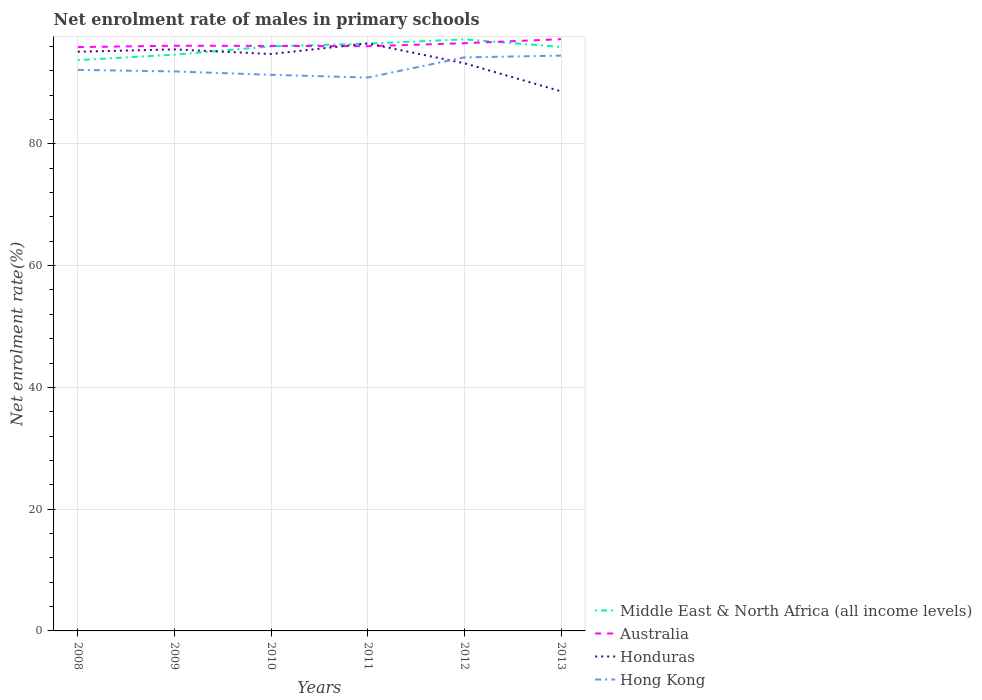How many different coloured lines are there?
Your answer should be compact. 4. Does the line corresponding to Honduras intersect with the line corresponding to Hong Kong?
Offer a very short reply. Yes. Is the number of lines equal to the number of legend labels?
Provide a succinct answer. Yes. Across all years, what is the maximum net enrolment rate of males in primary schools in Honduras?
Offer a very short reply. 88.63. In which year was the net enrolment rate of males in primary schools in Hong Kong maximum?
Make the answer very short. 2011. What is the total net enrolment rate of males in primary schools in Honduras in the graph?
Provide a short and direct response. 0.76. What is the difference between the highest and the second highest net enrolment rate of males in primary schools in Honduras?
Your response must be concise. 7.86. What is the difference between the highest and the lowest net enrolment rate of males in primary schools in Middle East & North Africa (all income levels)?
Provide a succinct answer. 4. Is the net enrolment rate of males in primary schools in Middle East & North Africa (all income levels) strictly greater than the net enrolment rate of males in primary schools in Australia over the years?
Offer a very short reply. No. How many lines are there?
Keep it short and to the point. 4. What is the difference between two consecutive major ticks on the Y-axis?
Ensure brevity in your answer.  20. Does the graph contain grids?
Your answer should be compact. Yes. How are the legend labels stacked?
Your answer should be very brief. Vertical. What is the title of the graph?
Ensure brevity in your answer.  Net enrolment rate of males in primary schools. What is the label or title of the Y-axis?
Keep it short and to the point. Net enrolment rate(%). What is the Net enrolment rate(%) in Middle East & North Africa (all income levels) in 2008?
Your response must be concise. 93.74. What is the Net enrolment rate(%) of Australia in 2008?
Your answer should be very brief. 95.89. What is the Net enrolment rate(%) in Honduras in 2008?
Your answer should be very brief. 95.13. What is the Net enrolment rate(%) in Hong Kong in 2008?
Make the answer very short. 92.14. What is the Net enrolment rate(%) of Middle East & North Africa (all income levels) in 2009?
Keep it short and to the point. 94.65. What is the Net enrolment rate(%) in Australia in 2009?
Ensure brevity in your answer.  96.11. What is the Net enrolment rate(%) in Honduras in 2009?
Offer a terse response. 95.51. What is the Net enrolment rate(%) of Hong Kong in 2009?
Your response must be concise. 91.89. What is the Net enrolment rate(%) in Middle East & North Africa (all income levels) in 2010?
Offer a terse response. 96.01. What is the Net enrolment rate(%) in Australia in 2010?
Provide a succinct answer. 96.09. What is the Net enrolment rate(%) of Honduras in 2010?
Make the answer very short. 94.75. What is the Net enrolment rate(%) of Hong Kong in 2010?
Give a very brief answer. 91.34. What is the Net enrolment rate(%) in Middle East & North Africa (all income levels) in 2011?
Ensure brevity in your answer.  96.46. What is the Net enrolment rate(%) in Australia in 2011?
Offer a terse response. 96.03. What is the Net enrolment rate(%) in Honduras in 2011?
Your answer should be very brief. 96.49. What is the Net enrolment rate(%) in Hong Kong in 2011?
Offer a terse response. 90.89. What is the Net enrolment rate(%) of Middle East & North Africa (all income levels) in 2012?
Ensure brevity in your answer.  97.16. What is the Net enrolment rate(%) of Australia in 2012?
Provide a succinct answer. 96.53. What is the Net enrolment rate(%) in Honduras in 2012?
Provide a short and direct response. 93.24. What is the Net enrolment rate(%) in Hong Kong in 2012?
Offer a very short reply. 94.2. What is the Net enrolment rate(%) in Middle East & North Africa (all income levels) in 2013?
Make the answer very short. 95.92. What is the Net enrolment rate(%) in Australia in 2013?
Provide a succinct answer. 97.19. What is the Net enrolment rate(%) of Honduras in 2013?
Your answer should be very brief. 88.63. What is the Net enrolment rate(%) of Hong Kong in 2013?
Offer a very short reply. 94.49. Across all years, what is the maximum Net enrolment rate(%) of Middle East & North Africa (all income levels)?
Keep it short and to the point. 97.16. Across all years, what is the maximum Net enrolment rate(%) of Australia?
Make the answer very short. 97.19. Across all years, what is the maximum Net enrolment rate(%) in Honduras?
Give a very brief answer. 96.49. Across all years, what is the maximum Net enrolment rate(%) in Hong Kong?
Offer a terse response. 94.49. Across all years, what is the minimum Net enrolment rate(%) in Middle East & North Africa (all income levels)?
Provide a succinct answer. 93.74. Across all years, what is the minimum Net enrolment rate(%) of Australia?
Offer a terse response. 95.89. Across all years, what is the minimum Net enrolment rate(%) of Honduras?
Your answer should be compact. 88.63. Across all years, what is the minimum Net enrolment rate(%) of Hong Kong?
Ensure brevity in your answer.  90.89. What is the total Net enrolment rate(%) of Middle East & North Africa (all income levels) in the graph?
Offer a very short reply. 573.94. What is the total Net enrolment rate(%) in Australia in the graph?
Ensure brevity in your answer.  577.84. What is the total Net enrolment rate(%) in Honduras in the graph?
Your answer should be compact. 563.76. What is the total Net enrolment rate(%) of Hong Kong in the graph?
Ensure brevity in your answer.  554.95. What is the difference between the Net enrolment rate(%) in Middle East & North Africa (all income levels) in 2008 and that in 2009?
Make the answer very short. -0.9. What is the difference between the Net enrolment rate(%) in Australia in 2008 and that in 2009?
Give a very brief answer. -0.23. What is the difference between the Net enrolment rate(%) in Honduras in 2008 and that in 2009?
Ensure brevity in your answer.  -0.38. What is the difference between the Net enrolment rate(%) in Hong Kong in 2008 and that in 2009?
Make the answer very short. 0.25. What is the difference between the Net enrolment rate(%) of Middle East & North Africa (all income levels) in 2008 and that in 2010?
Your answer should be very brief. -2.27. What is the difference between the Net enrolment rate(%) of Australia in 2008 and that in 2010?
Offer a terse response. -0.2. What is the difference between the Net enrolment rate(%) in Honduras in 2008 and that in 2010?
Offer a terse response. 0.38. What is the difference between the Net enrolment rate(%) in Hong Kong in 2008 and that in 2010?
Keep it short and to the point. 0.81. What is the difference between the Net enrolment rate(%) of Middle East & North Africa (all income levels) in 2008 and that in 2011?
Make the answer very short. -2.72. What is the difference between the Net enrolment rate(%) of Australia in 2008 and that in 2011?
Provide a succinct answer. -0.15. What is the difference between the Net enrolment rate(%) of Honduras in 2008 and that in 2011?
Make the answer very short. -1.36. What is the difference between the Net enrolment rate(%) in Hong Kong in 2008 and that in 2011?
Offer a very short reply. 1.25. What is the difference between the Net enrolment rate(%) of Middle East & North Africa (all income levels) in 2008 and that in 2012?
Keep it short and to the point. -3.42. What is the difference between the Net enrolment rate(%) of Australia in 2008 and that in 2012?
Provide a short and direct response. -0.64. What is the difference between the Net enrolment rate(%) of Honduras in 2008 and that in 2012?
Your answer should be very brief. 1.89. What is the difference between the Net enrolment rate(%) of Hong Kong in 2008 and that in 2012?
Your answer should be very brief. -2.05. What is the difference between the Net enrolment rate(%) in Middle East & North Africa (all income levels) in 2008 and that in 2013?
Your answer should be very brief. -2.17. What is the difference between the Net enrolment rate(%) in Australia in 2008 and that in 2013?
Keep it short and to the point. -1.3. What is the difference between the Net enrolment rate(%) of Honduras in 2008 and that in 2013?
Give a very brief answer. 6.5. What is the difference between the Net enrolment rate(%) in Hong Kong in 2008 and that in 2013?
Keep it short and to the point. -2.34. What is the difference between the Net enrolment rate(%) in Middle East & North Africa (all income levels) in 2009 and that in 2010?
Your answer should be compact. -1.37. What is the difference between the Net enrolment rate(%) in Australia in 2009 and that in 2010?
Offer a very short reply. 0.03. What is the difference between the Net enrolment rate(%) in Honduras in 2009 and that in 2010?
Provide a short and direct response. 0.76. What is the difference between the Net enrolment rate(%) in Hong Kong in 2009 and that in 2010?
Offer a terse response. 0.56. What is the difference between the Net enrolment rate(%) of Middle East & North Africa (all income levels) in 2009 and that in 2011?
Your answer should be compact. -1.82. What is the difference between the Net enrolment rate(%) in Australia in 2009 and that in 2011?
Keep it short and to the point. 0.08. What is the difference between the Net enrolment rate(%) of Honduras in 2009 and that in 2011?
Your answer should be compact. -0.98. What is the difference between the Net enrolment rate(%) of Middle East & North Africa (all income levels) in 2009 and that in 2012?
Your response must be concise. -2.51. What is the difference between the Net enrolment rate(%) in Australia in 2009 and that in 2012?
Give a very brief answer. -0.42. What is the difference between the Net enrolment rate(%) of Honduras in 2009 and that in 2012?
Keep it short and to the point. 2.28. What is the difference between the Net enrolment rate(%) in Hong Kong in 2009 and that in 2012?
Your answer should be compact. -2.31. What is the difference between the Net enrolment rate(%) of Middle East & North Africa (all income levels) in 2009 and that in 2013?
Give a very brief answer. -1.27. What is the difference between the Net enrolment rate(%) of Australia in 2009 and that in 2013?
Your answer should be compact. -1.07. What is the difference between the Net enrolment rate(%) in Honduras in 2009 and that in 2013?
Make the answer very short. 6.88. What is the difference between the Net enrolment rate(%) of Hong Kong in 2009 and that in 2013?
Your answer should be very brief. -2.6. What is the difference between the Net enrolment rate(%) of Middle East & North Africa (all income levels) in 2010 and that in 2011?
Your answer should be compact. -0.45. What is the difference between the Net enrolment rate(%) of Australia in 2010 and that in 2011?
Your response must be concise. 0.05. What is the difference between the Net enrolment rate(%) in Honduras in 2010 and that in 2011?
Ensure brevity in your answer.  -1.74. What is the difference between the Net enrolment rate(%) in Hong Kong in 2010 and that in 2011?
Ensure brevity in your answer.  0.45. What is the difference between the Net enrolment rate(%) of Middle East & North Africa (all income levels) in 2010 and that in 2012?
Provide a short and direct response. -1.14. What is the difference between the Net enrolment rate(%) of Australia in 2010 and that in 2012?
Your answer should be compact. -0.45. What is the difference between the Net enrolment rate(%) of Honduras in 2010 and that in 2012?
Your answer should be very brief. 1.52. What is the difference between the Net enrolment rate(%) of Hong Kong in 2010 and that in 2012?
Your answer should be very brief. -2.86. What is the difference between the Net enrolment rate(%) in Middle East & North Africa (all income levels) in 2010 and that in 2013?
Provide a short and direct response. 0.1. What is the difference between the Net enrolment rate(%) in Australia in 2010 and that in 2013?
Your answer should be compact. -1.1. What is the difference between the Net enrolment rate(%) of Honduras in 2010 and that in 2013?
Ensure brevity in your answer.  6.12. What is the difference between the Net enrolment rate(%) in Hong Kong in 2010 and that in 2013?
Offer a terse response. -3.15. What is the difference between the Net enrolment rate(%) of Middle East & North Africa (all income levels) in 2011 and that in 2012?
Give a very brief answer. -0.7. What is the difference between the Net enrolment rate(%) of Australia in 2011 and that in 2012?
Your answer should be very brief. -0.5. What is the difference between the Net enrolment rate(%) of Honduras in 2011 and that in 2012?
Your answer should be very brief. 3.26. What is the difference between the Net enrolment rate(%) of Hong Kong in 2011 and that in 2012?
Give a very brief answer. -3.31. What is the difference between the Net enrolment rate(%) in Middle East & North Africa (all income levels) in 2011 and that in 2013?
Provide a succinct answer. 0.55. What is the difference between the Net enrolment rate(%) of Australia in 2011 and that in 2013?
Ensure brevity in your answer.  -1.15. What is the difference between the Net enrolment rate(%) of Honduras in 2011 and that in 2013?
Your answer should be very brief. 7.86. What is the difference between the Net enrolment rate(%) in Hong Kong in 2011 and that in 2013?
Ensure brevity in your answer.  -3.6. What is the difference between the Net enrolment rate(%) of Middle East & North Africa (all income levels) in 2012 and that in 2013?
Your response must be concise. 1.24. What is the difference between the Net enrolment rate(%) in Australia in 2012 and that in 2013?
Your answer should be very brief. -0.66. What is the difference between the Net enrolment rate(%) in Honduras in 2012 and that in 2013?
Your response must be concise. 4.61. What is the difference between the Net enrolment rate(%) in Hong Kong in 2012 and that in 2013?
Keep it short and to the point. -0.29. What is the difference between the Net enrolment rate(%) in Middle East & North Africa (all income levels) in 2008 and the Net enrolment rate(%) in Australia in 2009?
Offer a very short reply. -2.37. What is the difference between the Net enrolment rate(%) of Middle East & North Africa (all income levels) in 2008 and the Net enrolment rate(%) of Honduras in 2009?
Provide a succinct answer. -1.77. What is the difference between the Net enrolment rate(%) of Middle East & North Africa (all income levels) in 2008 and the Net enrolment rate(%) of Hong Kong in 2009?
Provide a short and direct response. 1.85. What is the difference between the Net enrolment rate(%) of Australia in 2008 and the Net enrolment rate(%) of Honduras in 2009?
Your answer should be very brief. 0.38. What is the difference between the Net enrolment rate(%) in Australia in 2008 and the Net enrolment rate(%) in Hong Kong in 2009?
Keep it short and to the point. 3.99. What is the difference between the Net enrolment rate(%) of Honduras in 2008 and the Net enrolment rate(%) of Hong Kong in 2009?
Ensure brevity in your answer.  3.24. What is the difference between the Net enrolment rate(%) in Middle East & North Africa (all income levels) in 2008 and the Net enrolment rate(%) in Australia in 2010?
Ensure brevity in your answer.  -2.34. What is the difference between the Net enrolment rate(%) of Middle East & North Africa (all income levels) in 2008 and the Net enrolment rate(%) of Honduras in 2010?
Ensure brevity in your answer.  -1.01. What is the difference between the Net enrolment rate(%) in Middle East & North Africa (all income levels) in 2008 and the Net enrolment rate(%) in Hong Kong in 2010?
Provide a succinct answer. 2.41. What is the difference between the Net enrolment rate(%) in Australia in 2008 and the Net enrolment rate(%) in Honduras in 2010?
Provide a succinct answer. 1.13. What is the difference between the Net enrolment rate(%) in Australia in 2008 and the Net enrolment rate(%) in Hong Kong in 2010?
Offer a very short reply. 4.55. What is the difference between the Net enrolment rate(%) of Honduras in 2008 and the Net enrolment rate(%) of Hong Kong in 2010?
Make the answer very short. 3.79. What is the difference between the Net enrolment rate(%) in Middle East & North Africa (all income levels) in 2008 and the Net enrolment rate(%) in Australia in 2011?
Provide a short and direct response. -2.29. What is the difference between the Net enrolment rate(%) of Middle East & North Africa (all income levels) in 2008 and the Net enrolment rate(%) of Honduras in 2011?
Offer a very short reply. -2.75. What is the difference between the Net enrolment rate(%) of Middle East & North Africa (all income levels) in 2008 and the Net enrolment rate(%) of Hong Kong in 2011?
Offer a very short reply. 2.85. What is the difference between the Net enrolment rate(%) in Australia in 2008 and the Net enrolment rate(%) in Honduras in 2011?
Ensure brevity in your answer.  -0.61. What is the difference between the Net enrolment rate(%) in Australia in 2008 and the Net enrolment rate(%) in Hong Kong in 2011?
Provide a short and direct response. 5. What is the difference between the Net enrolment rate(%) of Honduras in 2008 and the Net enrolment rate(%) of Hong Kong in 2011?
Give a very brief answer. 4.24. What is the difference between the Net enrolment rate(%) in Middle East & North Africa (all income levels) in 2008 and the Net enrolment rate(%) in Australia in 2012?
Offer a terse response. -2.79. What is the difference between the Net enrolment rate(%) in Middle East & North Africa (all income levels) in 2008 and the Net enrolment rate(%) in Honduras in 2012?
Ensure brevity in your answer.  0.51. What is the difference between the Net enrolment rate(%) of Middle East & North Africa (all income levels) in 2008 and the Net enrolment rate(%) of Hong Kong in 2012?
Make the answer very short. -0.46. What is the difference between the Net enrolment rate(%) of Australia in 2008 and the Net enrolment rate(%) of Honduras in 2012?
Give a very brief answer. 2.65. What is the difference between the Net enrolment rate(%) of Australia in 2008 and the Net enrolment rate(%) of Hong Kong in 2012?
Offer a terse response. 1.69. What is the difference between the Net enrolment rate(%) of Honduras in 2008 and the Net enrolment rate(%) of Hong Kong in 2012?
Your response must be concise. 0.93. What is the difference between the Net enrolment rate(%) of Middle East & North Africa (all income levels) in 2008 and the Net enrolment rate(%) of Australia in 2013?
Provide a succinct answer. -3.45. What is the difference between the Net enrolment rate(%) in Middle East & North Africa (all income levels) in 2008 and the Net enrolment rate(%) in Honduras in 2013?
Ensure brevity in your answer.  5.11. What is the difference between the Net enrolment rate(%) of Middle East & North Africa (all income levels) in 2008 and the Net enrolment rate(%) of Hong Kong in 2013?
Provide a short and direct response. -0.75. What is the difference between the Net enrolment rate(%) in Australia in 2008 and the Net enrolment rate(%) in Honduras in 2013?
Your answer should be compact. 7.26. What is the difference between the Net enrolment rate(%) of Australia in 2008 and the Net enrolment rate(%) of Hong Kong in 2013?
Your response must be concise. 1.4. What is the difference between the Net enrolment rate(%) in Honduras in 2008 and the Net enrolment rate(%) in Hong Kong in 2013?
Your response must be concise. 0.64. What is the difference between the Net enrolment rate(%) of Middle East & North Africa (all income levels) in 2009 and the Net enrolment rate(%) of Australia in 2010?
Make the answer very short. -1.44. What is the difference between the Net enrolment rate(%) of Middle East & North Africa (all income levels) in 2009 and the Net enrolment rate(%) of Honduras in 2010?
Your answer should be very brief. -0.11. What is the difference between the Net enrolment rate(%) in Middle East & North Africa (all income levels) in 2009 and the Net enrolment rate(%) in Hong Kong in 2010?
Ensure brevity in your answer.  3.31. What is the difference between the Net enrolment rate(%) in Australia in 2009 and the Net enrolment rate(%) in Honduras in 2010?
Your answer should be compact. 1.36. What is the difference between the Net enrolment rate(%) in Australia in 2009 and the Net enrolment rate(%) in Hong Kong in 2010?
Provide a short and direct response. 4.78. What is the difference between the Net enrolment rate(%) of Honduras in 2009 and the Net enrolment rate(%) of Hong Kong in 2010?
Offer a very short reply. 4.18. What is the difference between the Net enrolment rate(%) in Middle East & North Africa (all income levels) in 2009 and the Net enrolment rate(%) in Australia in 2011?
Offer a very short reply. -1.39. What is the difference between the Net enrolment rate(%) in Middle East & North Africa (all income levels) in 2009 and the Net enrolment rate(%) in Honduras in 2011?
Provide a succinct answer. -1.85. What is the difference between the Net enrolment rate(%) in Middle East & North Africa (all income levels) in 2009 and the Net enrolment rate(%) in Hong Kong in 2011?
Your response must be concise. 3.75. What is the difference between the Net enrolment rate(%) of Australia in 2009 and the Net enrolment rate(%) of Honduras in 2011?
Provide a short and direct response. -0.38. What is the difference between the Net enrolment rate(%) of Australia in 2009 and the Net enrolment rate(%) of Hong Kong in 2011?
Make the answer very short. 5.22. What is the difference between the Net enrolment rate(%) of Honduras in 2009 and the Net enrolment rate(%) of Hong Kong in 2011?
Give a very brief answer. 4.62. What is the difference between the Net enrolment rate(%) in Middle East & North Africa (all income levels) in 2009 and the Net enrolment rate(%) in Australia in 2012?
Your response must be concise. -1.89. What is the difference between the Net enrolment rate(%) of Middle East & North Africa (all income levels) in 2009 and the Net enrolment rate(%) of Honduras in 2012?
Provide a short and direct response. 1.41. What is the difference between the Net enrolment rate(%) of Middle East & North Africa (all income levels) in 2009 and the Net enrolment rate(%) of Hong Kong in 2012?
Your answer should be compact. 0.45. What is the difference between the Net enrolment rate(%) of Australia in 2009 and the Net enrolment rate(%) of Honduras in 2012?
Offer a very short reply. 2.88. What is the difference between the Net enrolment rate(%) of Australia in 2009 and the Net enrolment rate(%) of Hong Kong in 2012?
Your response must be concise. 1.92. What is the difference between the Net enrolment rate(%) of Honduras in 2009 and the Net enrolment rate(%) of Hong Kong in 2012?
Your answer should be very brief. 1.31. What is the difference between the Net enrolment rate(%) in Middle East & North Africa (all income levels) in 2009 and the Net enrolment rate(%) in Australia in 2013?
Your response must be concise. -2.54. What is the difference between the Net enrolment rate(%) in Middle East & North Africa (all income levels) in 2009 and the Net enrolment rate(%) in Honduras in 2013?
Offer a very short reply. 6.02. What is the difference between the Net enrolment rate(%) in Middle East & North Africa (all income levels) in 2009 and the Net enrolment rate(%) in Hong Kong in 2013?
Give a very brief answer. 0.16. What is the difference between the Net enrolment rate(%) of Australia in 2009 and the Net enrolment rate(%) of Honduras in 2013?
Keep it short and to the point. 7.48. What is the difference between the Net enrolment rate(%) of Australia in 2009 and the Net enrolment rate(%) of Hong Kong in 2013?
Give a very brief answer. 1.62. What is the difference between the Net enrolment rate(%) of Honduras in 2009 and the Net enrolment rate(%) of Hong Kong in 2013?
Your answer should be very brief. 1.02. What is the difference between the Net enrolment rate(%) in Middle East & North Africa (all income levels) in 2010 and the Net enrolment rate(%) in Australia in 2011?
Make the answer very short. -0.02. What is the difference between the Net enrolment rate(%) in Middle East & North Africa (all income levels) in 2010 and the Net enrolment rate(%) in Honduras in 2011?
Your response must be concise. -0.48. What is the difference between the Net enrolment rate(%) in Middle East & North Africa (all income levels) in 2010 and the Net enrolment rate(%) in Hong Kong in 2011?
Ensure brevity in your answer.  5.12. What is the difference between the Net enrolment rate(%) in Australia in 2010 and the Net enrolment rate(%) in Honduras in 2011?
Your answer should be compact. -0.41. What is the difference between the Net enrolment rate(%) of Australia in 2010 and the Net enrolment rate(%) of Hong Kong in 2011?
Give a very brief answer. 5.2. What is the difference between the Net enrolment rate(%) in Honduras in 2010 and the Net enrolment rate(%) in Hong Kong in 2011?
Your response must be concise. 3.86. What is the difference between the Net enrolment rate(%) of Middle East & North Africa (all income levels) in 2010 and the Net enrolment rate(%) of Australia in 2012?
Offer a terse response. -0.52. What is the difference between the Net enrolment rate(%) of Middle East & North Africa (all income levels) in 2010 and the Net enrolment rate(%) of Honduras in 2012?
Offer a very short reply. 2.78. What is the difference between the Net enrolment rate(%) in Middle East & North Africa (all income levels) in 2010 and the Net enrolment rate(%) in Hong Kong in 2012?
Your response must be concise. 1.82. What is the difference between the Net enrolment rate(%) in Australia in 2010 and the Net enrolment rate(%) in Honduras in 2012?
Provide a short and direct response. 2.85. What is the difference between the Net enrolment rate(%) in Australia in 2010 and the Net enrolment rate(%) in Hong Kong in 2012?
Your response must be concise. 1.89. What is the difference between the Net enrolment rate(%) in Honduras in 2010 and the Net enrolment rate(%) in Hong Kong in 2012?
Offer a very short reply. 0.56. What is the difference between the Net enrolment rate(%) in Middle East & North Africa (all income levels) in 2010 and the Net enrolment rate(%) in Australia in 2013?
Keep it short and to the point. -1.17. What is the difference between the Net enrolment rate(%) of Middle East & North Africa (all income levels) in 2010 and the Net enrolment rate(%) of Honduras in 2013?
Provide a short and direct response. 7.38. What is the difference between the Net enrolment rate(%) of Middle East & North Africa (all income levels) in 2010 and the Net enrolment rate(%) of Hong Kong in 2013?
Provide a short and direct response. 1.53. What is the difference between the Net enrolment rate(%) of Australia in 2010 and the Net enrolment rate(%) of Honduras in 2013?
Make the answer very short. 7.46. What is the difference between the Net enrolment rate(%) of Australia in 2010 and the Net enrolment rate(%) of Hong Kong in 2013?
Ensure brevity in your answer.  1.6. What is the difference between the Net enrolment rate(%) in Honduras in 2010 and the Net enrolment rate(%) in Hong Kong in 2013?
Provide a short and direct response. 0.26. What is the difference between the Net enrolment rate(%) in Middle East & North Africa (all income levels) in 2011 and the Net enrolment rate(%) in Australia in 2012?
Offer a terse response. -0.07. What is the difference between the Net enrolment rate(%) of Middle East & North Africa (all income levels) in 2011 and the Net enrolment rate(%) of Honduras in 2012?
Your response must be concise. 3.23. What is the difference between the Net enrolment rate(%) in Middle East & North Africa (all income levels) in 2011 and the Net enrolment rate(%) in Hong Kong in 2012?
Provide a short and direct response. 2.26. What is the difference between the Net enrolment rate(%) in Australia in 2011 and the Net enrolment rate(%) in Honduras in 2012?
Your answer should be very brief. 2.8. What is the difference between the Net enrolment rate(%) of Australia in 2011 and the Net enrolment rate(%) of Hong Kong in 2012?
Your answer should be very brief. 1.84. What is the difference between the Net enrolment rate(%) in Honduras in 2011 and the Net enrolment rate(%) in Hong Kong in 2012?
Give a very brief answer. 2.3. What is the difference between the Net enrolment rate(%) of Middle East & North Africa (all income levels) in 2011 and the Net enrolment rate(%) of Australia in 2013?
Offer a terse response. -0.73. What is the difference between the Net enrolment rate(%) of Middle East & North Africa (all income levels) in 2011 and the Net enrolment rate(%) of Honduras in 2013?
Your answer should be compact. 7.83. What is the difference between the Net enrolment rate(%) of Middle East & North Africa (all income levels) in 2011 and the Net enrolment rate(%) of Hong Kong in 2013?
Provide a succinct answer. 1.97. What is the difference between the Net enrolment rate(%) of Australia in 2011 and the Net enrolment rate(%) of Honduras in 2013?
Give a very brief answer. 7.4. What is the difference between the Net enrolment rate(%) of Australia in 2011 and the Net enrolment rate(%) of Hong Kong in 2013?
Make the answer very short. 1.54. What is the difference between the Net enrolment rate(%) of Honduras in 2011 and the Net enrolment rate(%) of Hong Kong in 2013?
Offer a terse response. 2. What is the difference between the Net enrolment rate(%) of Middle East & North Africa (all income levels) in 2012 and the Net enrolment rate(%) of Australia in 2013?
Provide a short and direct response. -0.03. What is the difference between the Net enrolment rate(%) in Middle East & North Africa (all income levels) in 2012 and the Net enrolment rate(%) in Honduras in 2013?
Make the answer very short. 8.53. What is the difference between the Net enrolment rate(%) in Middle East & North Africa (all income levels) in 2012 and the Net enrolment rate(%) in Hong Kong in 2013?
Keep it short and to the point. 2.67. What is the difference between the Net enrolment rate(%) of Australia in 2012 and the Net enrolment rate(%) of Honduras in 2013?
Make the answer very short. 7.9. What is the difference between the Net enrolment rate(%) of Australia in 2012 and the Net enrolment rate(%) of Hong Kong in 2013?
Keep it short and to the point. 2.04. What is the difference between the Net enrolment rate(%) in Honduras in 2012 and the Net enrolment rate(%) in Hong Kong in 2013?
Your answer should be very brief. -1.25. What is the average Net enrolment rate(%) in Middle East & North Africa (all income levels) per year?
Your answer should be compact. 95.66. What is the average Net enrolment rate(%) of Australia per year?
Offer a very short reply. 96.31. What is the average Net enrolment rate(%) of Honduras per year?
Your response must be concise. 93.96. What is the average Net enrolment rate(%) of Hong Kong per year?
Offer a very short reply. 92.49. In the year 2008, what is the difference between the Net enrolment rate(%) in Middle East & North Africa (all income levels) and Net enrolment rate(%) in Australia?
Your response must be concise. -2.14. In the year 2008, what is the difference between the Net enrolment rate(%) in Middle East & North Africa (all income levels) and Net enrolment rate(%) in Honduras?
Give a very brief answer. -1.39. In the year 2008, what is the difference between the Net enrolment rate(%) of Middle East & North Africa (all income levels) and Net enrolment rate(%) of Hong Kong?
Offer a very short reply. 1.6. In the year 2008, what is the difference between the Net enrolment rate(%) in Australia and Net enrolment rate(%) in Honduras?
Give a very brief answer. 0.76. In the year 2008, what is the difference between the Net enrolment rate(%) of Australia and Net enrolment rate(%) of Hong Kong?
Provide a succinct answer. 3.74. In the year 2008, what is the difference between the Net enrolment rate(%) of Honduras and Net enrolment rate(%) of Hong Kong?
Your response must be concise. 2.99. In the year 2009, what is the difference between the Net enrolment rate(%) in Middle East & North Africa (all income levels) and Net enrolment rate(%) in Australia?
Offer a very short reply. -1.47. In the year 2009, what is the difference between the Net enrolment rate(%) of Middle East & North Africa (all income levels) and Net enrolment rate(%) of Honduras?
Keep it short and to the point. -0.87. In the year 2009, what is the difference between the Net enrolment rate(%) in Middle East & North Africa (all income levels) and Net enrolment rate(%) in Hong Kong?
Your response must be concise. 2.75. In the year 2009, what is the difference between the Net enrolment rate(%) in Australia and Net enrolment rate(%) in Honduras?
Ensure brevity in your answer.  0.6. In the year 2009, what is the difference between the Net enrolment rate(%) of Australia and Net enrolment rate(%) of Hong Kong?
Keep it short and to the point. 4.22. In the year 2009, what is the difference between the Net enrolment rate(%) of Honduras and Net enrolment rate(%) of Hong Kong?
Offer a terse response. 3.62. In the year 2010, what is the difference between the Net enrolment rate(%) of Middle East & North Africa (all income levels) and Net enrolment rate(%) of Australia?
Provide a short and direct response. -0.07. In the year 2010, what is the difference between the Net enrolment rate(%) of Middle East & North Africa (all income levels) and Net enrolment rate(%) of Honduras?
Ensure brevity in your answer.  1.26. In the year 2010, what is the difference between the Net enrolment rate(%) of Middle East & North Africa (all income levels) and Net enrolment rate(%) of Hong Kong?
Give a very brief answer. 4.68. In the year 2010, what is the difference between the Net enrolment rate(%) of Australia and Net enrolment rate(%) of Honduras?
Offer a terse response. 1.33. In the year 2010, what is the difference between the Net enrolment rate(%) in Australia and Net enrolment rate(%) in Hong Kong?
Provide a succinct answer. 4.75. In the year 2010, what is the difference between the Net enrolment rate(%) in Honduras and Net enrolment rate(%) in Hong Kong?
Ensure brevity in your answer.  3.42. In the year 2011, what is the difference between the Net enrolment rate(%) in Middle East & North Africa (all income levels) and Net enrolment rate(%) in Australia?
Offer a terse response. 0.43. In the year 2011, what is the difference between the Net enrolment rate(%) of Middle East & North Africa (all income levels) and Net enrolment rate(%) of Honduras?
Offer a very short reply. -0.03. In the year 2011, what is the difference between the Net enrolment rate(%) of Middle East & North Africa (all income levels) and Net enrolment rate(%) of Hong Kong?
Offer a terse response. 5.57. In the year 2011, what is the difference between the Net enrolment rate(%) in Australia and Net enrolment rate(%) in Honduras?
Give a very brief answer. -0.46. In the year 2011, what is the difference between the Net enrolment rate(%) of Australia and Net enrolment rate(%) of Hong Kong?
Your answer should be compact. 5.14. In the year 2011, what is the difference between the Net enrolment rate(%) in Honduras and Net enrolment rate(%) in Hong Kong?
Provide a succinct answer. 5.6. In the year 2012, what is the difference between the Net enrolment rate(%) in Middle East & North Africa (all income levels) and Net enrolment rate(%) in Australia?
Offer a terse response. 0.63. In the year 2012, what is the difference between the Net enrolment rate(%) in Middle East & North Africa (all income levels) and Net enrolment rate(%) in Honduras?
Make the answer very short. 3.92. In the year 2012, what is the difference between the Net enrolment rate(%) of Middle East & North Africa (all income levels) and Net enrolment rate(%) of Hong Kong?
Your answer should be very brief. 2.96. In the year 2012, what is the difference between the Net enrolment rate(%) in Australia and Net enrolment rate(%) in Honduras?
Your answer should be very brief. 3.3. In the year 2012, what is the difference between the Net enrolment rate(%) in Australia and Net enrolment rate(%) in Hong Kong?
Ensure brevity in your answer.  2.33. In the year 2012, what is the difference between the Net enrolment rate(%) in Honduras and Net enrolment rate(%) in Hong Kong?
Keep it short and to the point. -0.96. In the year 2013, what is the difference between the Net enrolment rate(%) in Middle East & North Africa (all income levels) and Net enrolment rate(%) in Australia?
Your answer should be compact. -1.27. In the year 2013, what is the difference between the Net enrolment rate(%) in Middle East & North Africa (all income levels) and Net enrolment rate(%) in Honduras?
Offer a terse response. 7.29. In the year 2013, what is the difference between the Net enrolment rate(%) of Middle East & North Africa (all income levels) and Net enrolment rate(%) of Hong Kong?
Keep it short and to the point. 1.43. In the year 2013, what is the difference between the Net enrolment rate(%) of Australia and Net enrolment rate(%) of Honduras?
Ensure brevity in your answer.  8.56. In the year 2013, what is the difference between the Net enrolment rate(%) of Australia and Net enrolment rate(%) of Hong Kong?
Give a very brief answer. 2.7. In the year 2013, what is the difference between the Net enrolment rate(%) in Honduras and Net enrolment rate(%) in Hong Kong?
Your answer should be very brief. -5.86. What is the ratio of the Net enrolment rate(%) of Middle East & North Africa (all income levels) in 2008 to that in 2010?
Your answer should be very brief. 0.98. What is the ratio of the Net enrolment rate(%) of Australia in 2008 to that in 2010?
Provide a succinct answer. 1. What is the ratio of the Net enrolment rate(%) in Hong Kong in 2008 to that in 2010?
Provide a succinct answer. 1.01. What is the ratio of the Net enrolment rate(%) in Middle East & North Africa (all income levels) in 2008 to that in 2011?
Provide a short and direct response. 0.97. What is the ratio of the Net enrolment rate(%) of Honduras in 2008 to that in 2011?
Make the answer very short. 0.99. What is the ratio of the Net enrolment rate(%) of Hong Kong in 2008 to that in 2011?
Provide a short and direct response. 1.01. What is the ratio of the Net enrolment rate(%) of Middle East & North Africa (all income levels) in 2008 to that in 2012?
Your response must be concise. 0.96. What is the ratio of the Net enrolment rate(%) of Honduras in 2008 to that in 2012?
Offer a very short reply. 1.02. What is the ratio of the Net enrolment rate(%) in Hong Kong in 2008 to that in 2012?
Ensure brevity in your answer.  0.98. What is the ratio of the Net enrolment rate(%) of Middle East & North Africa (all income levels) in 2008 to that in 2013?
Your response must be concise. 0.98. What is the ratio of the Net enrolment rate(%) of Australia in 2008 to that in 2013?
Ensure brevity in your answer.  0.99. What is the ratio of the Net enrolment rate(%) of Honduras in 2008 to that in 2013?
Your answer should be compact. 1.07. What is the ratio of the Net enrolment rate(%) of Hong Kong in 2008 to that in 2013?
Provide a short and direct response. 0.98. What is the ratio of the Net enrolment rate(%) of Middle East & North Africa (all income levels) in 2009 to that in 2010?
Your response must be concise. 0.99. What is the ratio of the Net enrolment rate(%) in Middle East & North Africa (all income levels) in 2009 to that in 2011?
Provide a succinct answer. 0.98. What is the ratio of the Net enrolment rate(%) of Honduras in 2009 to that in 2011?
Provide a short and direct response. 0.99. What is the ratio of the Net enrolment rate(%) in Middle East & North Africa (all income levels) in 2009 to that in 2012?
Your answer should be very brief. 0.97. What is the ratio of the Net enrolment rate(%) in Honduras in 2009 to that in 2012?
Provide a short and direct response. 1.02. What is the ratio of the Net enrolment rate(%) of Hong Kong in 2009 to that in 2012?
Keep it short and to the point. 0.98. What is the ratio of the Net enrolment rate(%) of Middle East & North Africa (all income levels) in 2009 to that in 2013?
Keep it short and to the point. 0.99. What is the ratio of the Net enrolment rate(%) of Australia in 2009 to that in 2013?
Your answer should be compact. 0.99. What is the ratio of the Net enrolment rate(%) of Honduras in 2009 to that in 2013?
Provide a succinct answer. 1.08. What is the ratio of the Net enrolment rate(%) of Hong Kong in 2009 to that in 2013?
Your answer should be compact. 0.97. What is the ratio of the Net enrolment rate(%) of Australia in 2010 to that in 2011?
Offer a very short reply. 1. What is the ratio of the Net enrolment rate(%) in Honduras in 2010 to that in 2011?
Make the answer very short. 0.98. What is the ratio of the Net enrolment rate(%) in Hong Kong in 2010 to that in 2011?
Keep it short and to the point. 1. What is the ratio of the Net enrolment rate(%) of Honduras in 2010 to that in 2012?
Provide a succinct answer. 1.02. What is the ratio of the Net enrolment rate(%) of Hong Kong in 2010 to that in 2012?
Offer a terse response. 0.97. What is the ratio of the Net enrolment rate(%) of Australia in 2010 to that in 2013?
Provide a short and direct response. 0.99. What is the ratio of the Net enrolment rate(%) of Honduras in 2010 to that in 2013?
Your answer should be compact. 1.07. What is the ratio of the Net enrolment rate(%) of Hong Kong in 2010 to that in 2013?
Keep it short and to the point. 0.97. What is the ratio of the Net enrolment rate(%) of Middle East & North Africa (all income levels) in 2011 to that in 2012?
Ensure brevity in your answer.  0.99. What is the ratio of the Net enrolment rate(%) in Australia in 2011 to that in 2012?
Your answer should be compact. 0.99. What is the ratio of the Net enrolment rate(%) in Honduras in 2011 to that in 2012?
Ensure brevity in your answer.  1.03. What is the ratio of the Net enrolment rate(%) of Hong Kong in 2011 to that in 2012?
Your response must be concise. 0.96. What is the ratio of the Net enrolment rate(%) of Australia in 2011 to that in 2013?
Your response must be concise. 0.99. What is the ratio of the Net enrolment rate(%) of Honduras in 2011 to that in 2013?
Your response must be concise. 1.09. What is the ratio of the Net enrolment rate(%) of Hong Kong in 2011 to that in 2013?
Provide a short and direct response. 0.96. What is the ratio of the Net enrolment rate(%) of Australia in 2012 to that in 2013?
Your response must be concise. 0.99. What is the ratio of the Net enrolment rate(%) in Honduras in 2012 to that in 2013?
Ensure brevity in your answer.  1.05. What is the ratio of the Net enrolment rate(%) of Hong Kong in 2012 to that in 2013?
Keep it short and to the point. 1. What is the difference between the highest and the second highest Net enrolment rate(%) of Middle East & North Africa (all income levels)?
Provide a short and direct response. 0.7. What is the difference between the highest and the second highest Net enrolment rate(%) in Australia?
Your answer should be very brief. 0.66. What is the difference between the highest and the second highest Net enrolment rate(%) in Honduras?
Make the answer very short. 0.98. What is the difference between the highest and the second highest Net enrolment rate(%) in Hong Kong?
Make the answer very short. 0.29. What is the difference between the highest and the lowest Net enrolment rate(%) of Middle East & North Africa (all income levels)?
Your response must be concise. 3.42. What is the difference between the highest and the lowest Net enrolment rate(%) in Australia?
Offer a terse response. 1.3. What is the difference between the highest and the lowest Net enrolment rate(%) in Honduras?
Your answer should be very brief. 7.86. What is the difference between the highest and the lowest Net enrolment rate(%) of Hong Kong?
Your response must be concise. 3.6. 